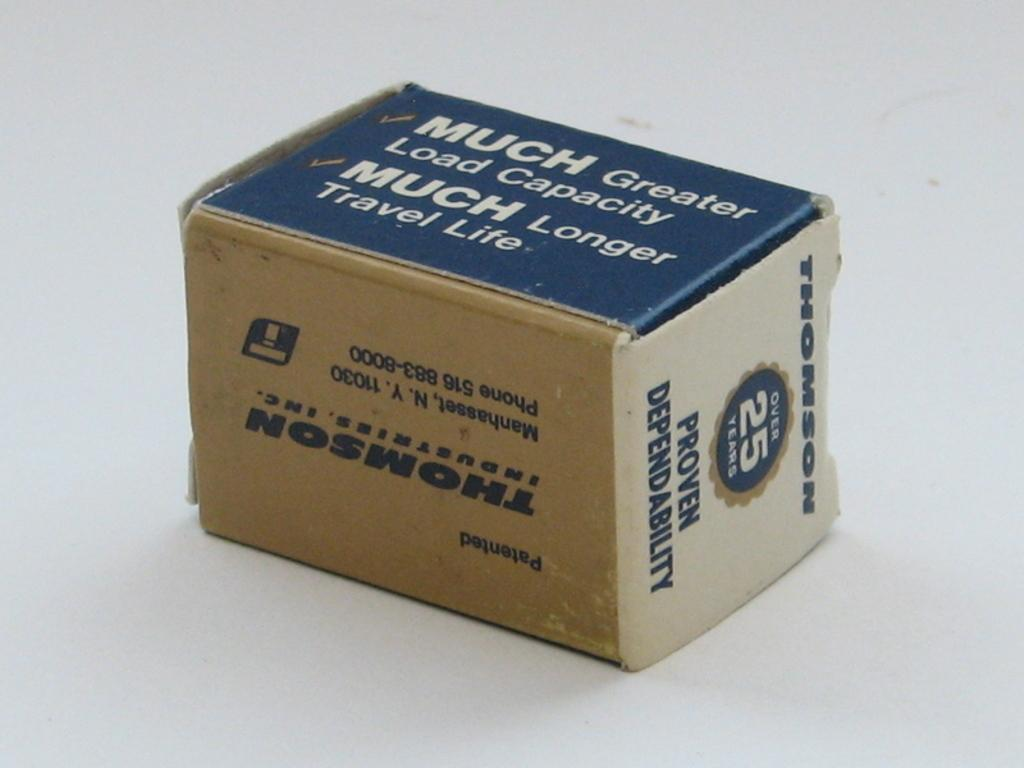<image>
Relay a brief, clear account of the picture shown. A box for Thomson brand has been around for over 25 years 